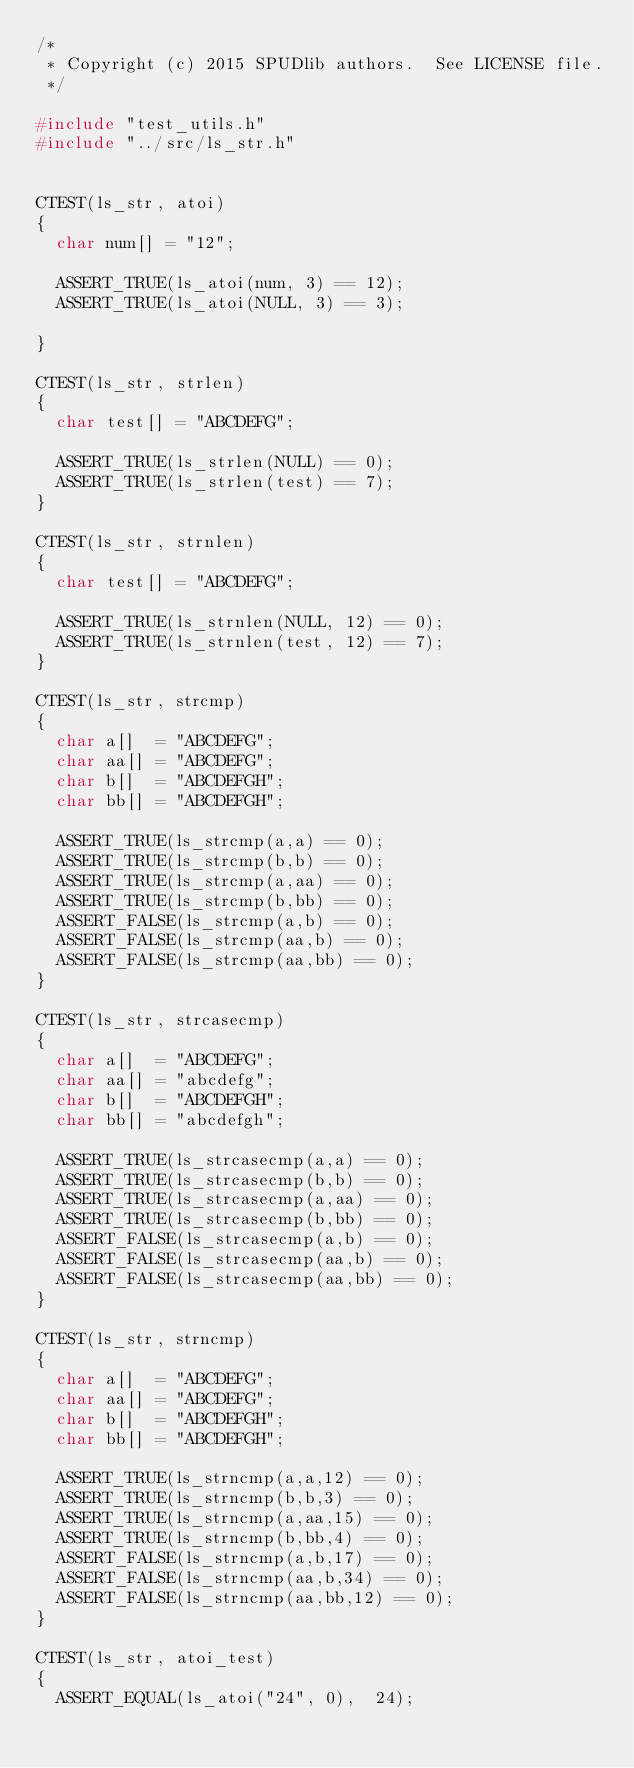Convert code to text. <code><loc_0><loc_0><loc_500><loc_500><_C_>/*
 * Copyright (c) 2015 SPUDlib authors.  See LICENSE file.
 */

#include "test_utils.h"
#include "../src/ls_str.h"


CTEST(ls_str, atoi)
{
  char num[] = "12";

  ASSERT_TRUE(ls_atoi(num, 3) == 12);
  ASSERT_TRUE(ls_atoi(NULL, 3) == 3);

}

CTEST(ls_str, strlen)
{
  char test[] = "ABCDEFG";

  ASSERT_TRUE(ls_strlen(NULL) == 0);
  ASSERT_TRUE(ls_strlen(test) == 7);
}

CTEST(ls_str, strnlen)
{
  char test[] = "ABCDEFG";

  ASSERT_TRUE(ls_strnlen(NULL, 12) == 0);
  ASSERT_TRUE(ls_strnlen(test, 12) == 7);
}

CTEST(ls_str, strcmp)
{
  char a[]  = "ABCDEFG";
  char aa[] = "ABCDEFG";
  char b[]  = "ABCDEFGH";
  char bb[] = "ABCDEFGH";

  ASSERT_TRUE(ls_strcmp(a,a) == 0);
  ASSERT_TRUE(ls_strcmp(b,b) == 0);
  ASSERT_TRUE(ls_strcmp(a,aa) == 0);
  ASSERT_TRUE(ls_strcmp(b,bb) == 0);
  ASSERT_FALSE(ls_strcmp(a,b) == 0);
  ASSERT_FALSE(ls_strcmp(aa,b) == 0);
  ASSERT_FALSE(ls_strcmp(aa,bb) == 0);
}

CTEST(ls_str, strcasecmp)
{
  char a[]  = "ABCDEFG";
  char aa[] = "abcdefg";
  char b[]  = "ABCDEFGH";
  char bb[] = "abcdefgh";

  ASSERT_TRUE(ls_strcasecmp(a,a) == 0);
  ASSERT_TRUE(ls_strcasecmp(b,b) == 0);
  ASSERT_TRUE(ls_strcasecmp(a,aa) == 0);
  ASSERT_TRUE(ls_strcasecmp(b,bb) == 0);
  ASSERT_FALSE(ls_strcasecmp(a,b) == 0);
  ASSERT_FALSE(ls_strcasecmp(aa,b) == 0);
  ASSERT_FALSE(ls_strcasecmp(aa,bb) == 0);
}

CTEST(ls_str, strncmp)
{
  char a[]  = "ABCDEFG";
  char aa[] = "ABCDEFG";
  char b[]  = "ABCDEFGH";
  char bb[] = "ABCDEFGH";

  ASSERT_TRUE(ls_strncmp(a,a,12) == 0);
  ASSERT_TRUE(ls_strncmp(b,b,3) == 0);
  ASSERT_TRUE(ls_strncmp(a,aa,15) == 0);
  ASSERT_TRUE(ls_strncmp(b,bb,4) == 0);
  ASSERT_FALSE(ls_strncmp(a,b,17) == 0);
  ASSERT_FALSE(ls_strncmp(aa,b,34) == 0);
  ASSERT_FALSE(ls_strncmp(aa,bb,12) == 0);
}

CTEST(ls_str, atoi_test)
{
  ASSERT_EQUAL(ls_atoi("24", 0),  24);</code> 